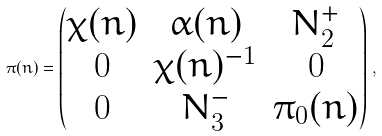<formula> <loc_0><loc_0><loc_500><loc_500>\pi ( n ) = \begin{pmatrix} \chi ( n ) & \alpha ( n ) & N _ { 2 } ^ { + } \\ 0 & \chi ( n ) ^ { - 1 } & 0 \\ 0 & N _ { 3 } ^ { - } & \pi _ { 0 } ( n ) \end{pmatrix} \, ,</formula> 